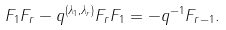<formula> <loc_0><loc_0><loc_500><loc_500>F _ { 1 } F _ { r } - q ^ { ( \lambda _ { 1 } , \lambda _ { r } ) } F _ { r } F _ { 1 } = - q ^ { - 1 } F _ { r - 1 } .</formula> 